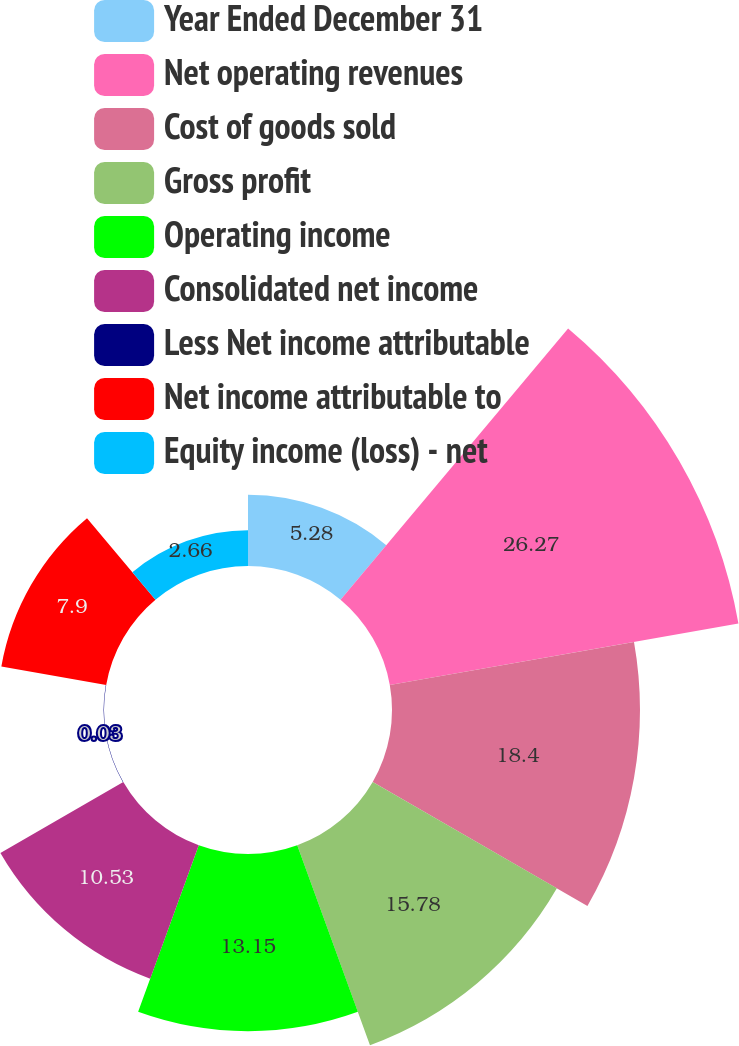Convert chart. <chart><loc_0><loc_0><loc_500><loc_500><pie_chart><fcel>Year Ended December 31<fcel>Net operating revenues<fcel>Cost of goods sold<fcel>Gross profit<fcel>Operating income<fcel>Consolidated net income<fcel>Less Net income attributable<fcel>Net income attributable to<fcel>Equity income (loss) - net<nl><fcel>5.28%<fcel>26.27%<fcel>18.4%<fcel>15.78%<fcel>13.15%<fcel>10.53%<fcel>0.03%<fcel>7.9%<fcel>2.66%<nl></chart> 